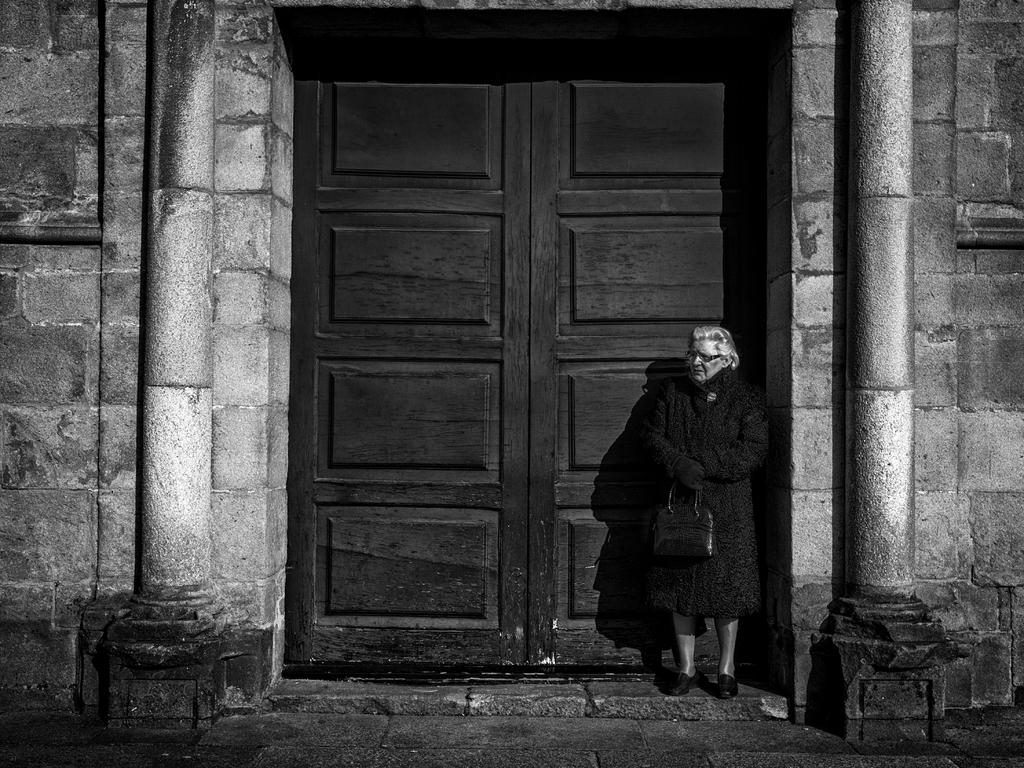What type of structure is visible in the image? There is a building in the image. What is the entrance to the building made of? There is a wooden door in the image. Who is present in the image? There is a woman standing in the image. What is the woman holding? The woman is holding a handbag. What accessory is the woman wearing? The woman is wearing spectacles. What color is the coat the woman is wearing? The woman is wearing a black coat. What type of needle is the woman using to sew on her stomach in the image? There is no needle or sewing activity present in the image. What type of bulb is illuminating the scene in the image? There is no bulb or artificial light source visible in the image. 